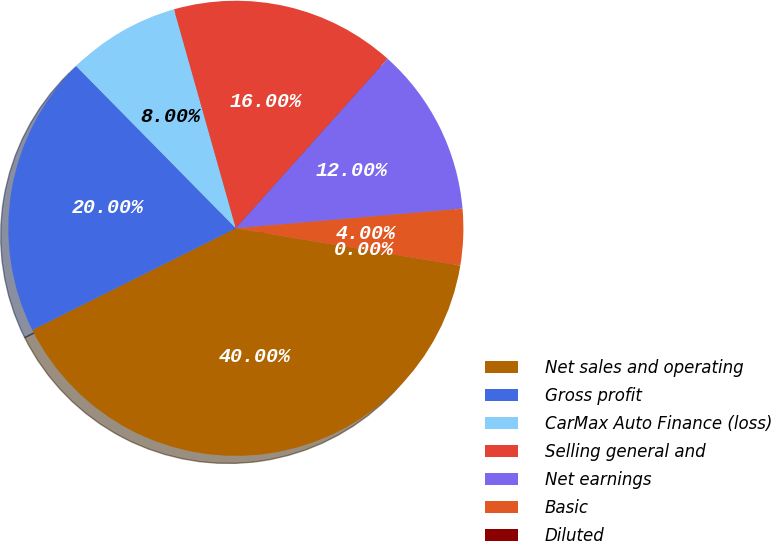Convert chart to OTSL. <chart><loc_0><loc_0><loc_500><loc_500><pie_chart><fcel>Net sales and operating<fcel>Gross profit<fcel>CarMax Auto Finance (loss)<fcel>Selling general and<fcel>Net earnings<fcel>Basic<fcel>Diluted<nl><fcel>40.0%<fcel>20.0%<fcel>8.0%<fcel>16.0%<fcel>12.0%<fcel>4.0%<fcel>0.0%<nl></chart> 